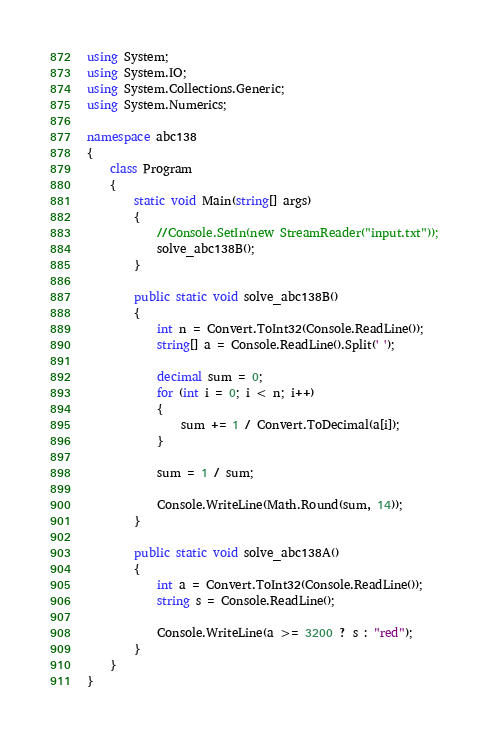Convert code to text. <code><loc_0><loc_0><loc_500><loc_500><_C#_>using System;
using System.IO;
using System.Collections.Generic;
using System.Numerics;

namespace abc138
{
    class Program
    {
        static void Main(string[] args)
        {
            //Console.SetIn(new StreamReader("input.txt"));
            solve_abc138B();
        }

        public static void solve_abc138B()
        {
            int n = Convert.ToInt32(Console.ReadLine());
            string[] a = Console.ReadLine().Split(' ');

            decimal sum = 0;
            for (int i = 0; i < n; i++)
            {
                sum += 1 / Convert.ToDecimal(a[i]);
            }

            sum = 1 / sum;

            Console.WriteLine(Math.Round(sum, 14));
        }

        public static void solve_abc138A()
        {
            int a = Convert.ToInt32(Console.ReadLine());
            string s = Console.ReadLine();

            Console.WriteLine(a >= 3200 ? s : "red");
        }
    }
}
</code> 